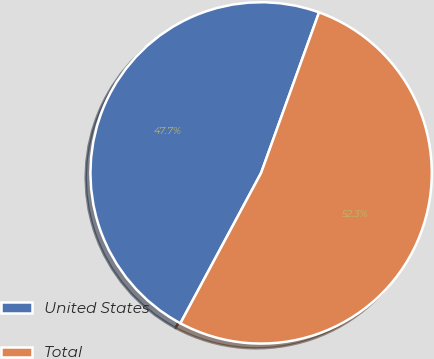Convert chart. <chart><loc_0><loc_0><loc_500><loc_500><pie_chart><fcel>United States<fcel>Total<nl><fcel>47.67%<fcel>52.33%<nl></chart> 